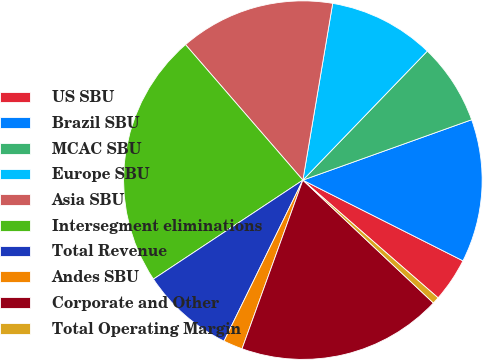<chart> <loc_0><loc_0><loc_500><loc_500><pie_chart><fcel>US SBU<fcel>Brazil SBU<fcel>MCAC SBU<fcel>Europe SBU<fcel>Asia SBU<fcel>Intersegment eliminations<fcel>Total Revenue<fcel>Andes SBU<fcel>Corporate and Other<fcel>Total Operating Margin<nl><fcel>3.97%<fcel>12.9%<fcel>7.32%<fcel>9.55%<fcel>14.02%<fcel>22.95%<fcel>8.44%<fcel>1.74%<fcel>18.49%<fcel>0.62%<nl></chart> 